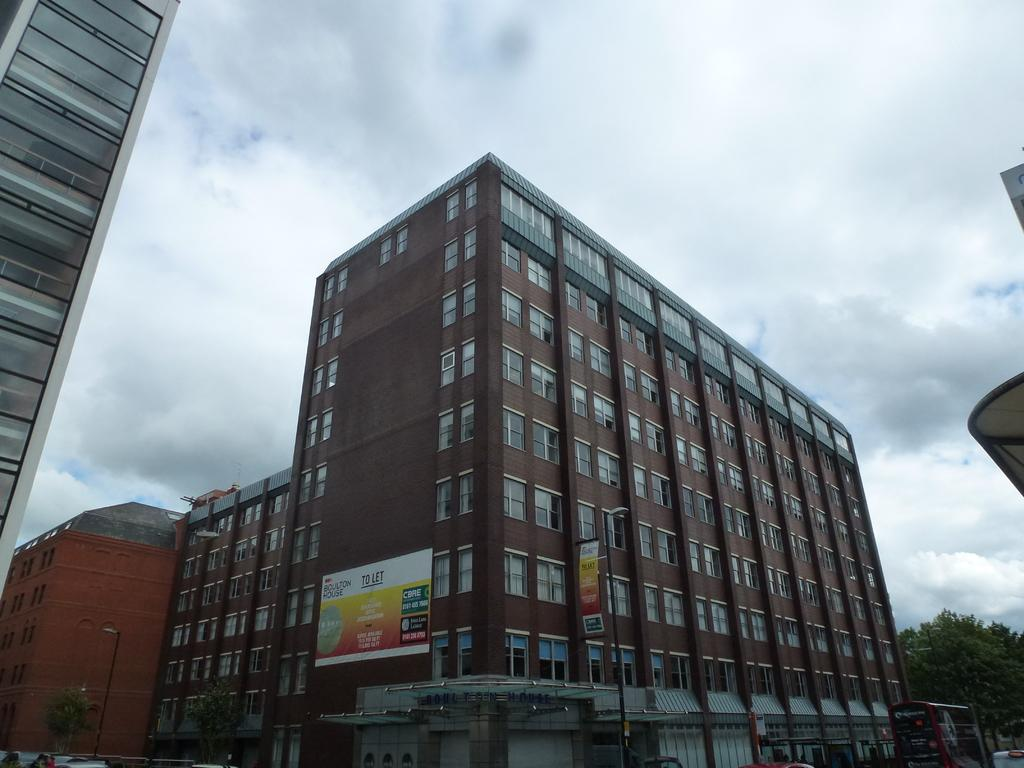What type of structures can be seen in the image? There are buildings in the image. What natural elements are present in the image? There are trees in the image. What type of street furniture can be seen in the image? There are light poles in the image. What type of advertisements are present in the image? There are hoardings in the image. What type of transportation is visible in the image? There are vehicles in the image. What is the weather like in the image? The sky is cloudy in the image. Where is the stove located in the image? There is no stove present in the image. What is your dad doing in the image? There is no person, let alone a specific individual like a dad, present in the image. 